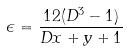<formula> <loc_0><loc_0><loc_500><loc_500>\epsilon = \frac { 1 2 ( D ^ { 3 } - 1 ) } { D x + y + 1 }</formula> 